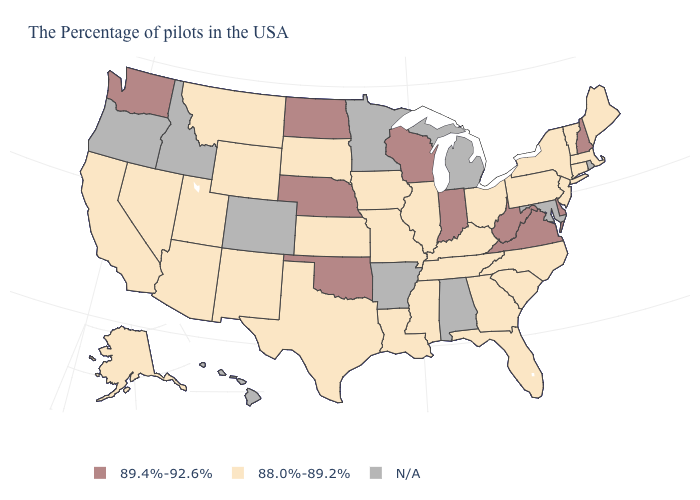How many symbols are there in the legend?
Answer briefly. 3. What is the value of North Carolina?
Write a very short answer. 88.0%-89.2%. What is the value of Hawaii?
Be succinct. N/A. What is the highest value in the USA?
Short answer required. 89.4%-92.6%. Does North Dakota have the highest value in the USA?
Be succinct. Yes. Name the states that have a value in the range 88.0%-89.2%?
Be succinct. Maine, Massachusetts, Vermont, Connecticut, New York, New Jersey, Pennsylvania, North Carolina, South Carolina, Ohio, Florida, Georgia, Kentucky, Tennessee, Illinois, Mississippi, Louisiana, Missouri, Iowa, Kansas, Texas, South Dakota, Wyoming, New Mexico, Utah, Montana, Arizona, Nevada, California, Alaska. Name the states that have a value in the range N/A?
Be succinct. Rhode Island, Maryland, Michigan, Alabama, Arkansas, Minnesota, Colorado, Idaho, Oregon, Hawaii. What is the lowest value in the South?
Write a very short answer. 88.0%-89.2%. What is the value of Arizona?
Give a very brief answer. 88.0%-89.2%. Which states hav the highest value in the West?
Keep it brief. Washington. What is the lowest value in the Northeast?
Concise answer only. 88.0%-89.2%. Does Louisiana have the highest value in the USA?
Short answer required. No. Name the states that have a value in the range 89.4%-92.6%?
Write a very short answer. New Hampshire, Delaware, Virginia, West Virginia, Indiana, Wisconsin, Nebraska, Oklahoma, North Dakota, Washington. 